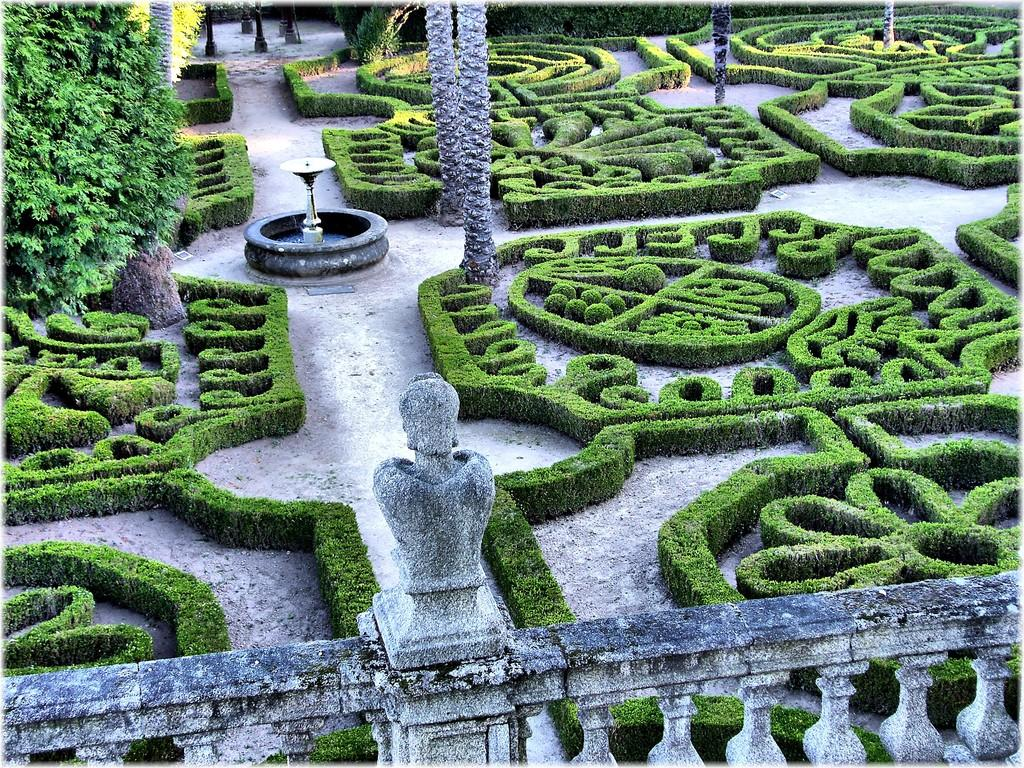What type of structure can be seen in the image? There is a rail in the image. What other natural elements are present in the image? There are plants and trees in the image. What is the main feature in the middle of the image? There is a fountain in the middle of the image. What type of quartz can be seen in the image? There is no quartz present in the image. How does the fountain blow water in the image? The fountain does not blow water in the image; it simply sprays water from its central feature. 